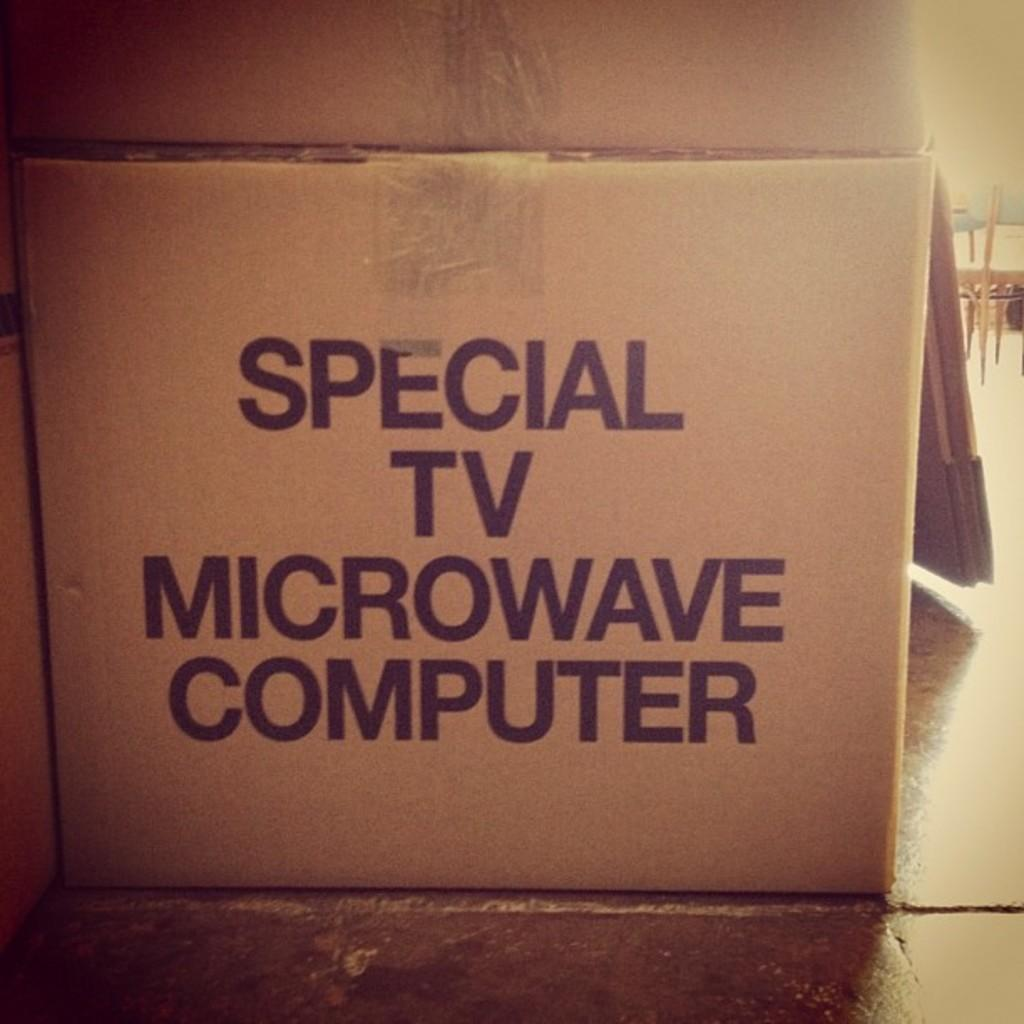<image>
Describe the image concisely. A cardboard box is curiously labeled special TV microwave computer. 